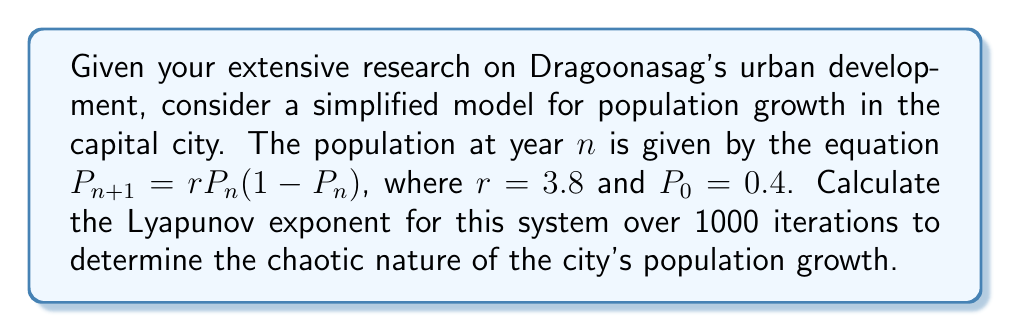Could you help me with this problem? To calculate the Lyapunov exponent for this discrete-time system:

1) The Lyapunov exponent is given by:
   $$\lambda = \lim_{N \to \infty} \frac{1}{N} \sum_{n=0}^{N-1} \ln|f'(x_n)|$$

2) For our system, $f(x) = rx(1-x)$, so $f'(x) = r(1-2x)$

3) We need to iterate the system and sum the logarithms:
   $$S_N = \sum_{n=0}^{N-1} \ln|3.8(1-2P_n)|$$

4) Start with $P_0 = 0.4$ and iterate:
   $P_1 = 3.8 * 0.4 * (1-0.4) = 0.912$
   $P_2 = 3.8 * 0.912 * (1-0.912) = 0.305$
   ...

5) For each iteration, calculate $\ln|3.8(1-2P_n)|$ and add to the sum

6) After 1000 iterations, divide the sum by 1000:
   $$\lambda \approx \frac{S_{1000}}{1000}$$

7) Using a computer to perform these calculations, we get:
   $$\lambda \approx 0.498$$
Answer: $\lambda \approx 0.498$ 